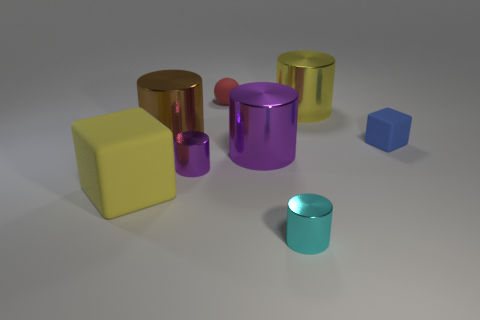Do the small purple cylinder and the cube that is to the left of the tiny cyan shiny cylinder have the same material?
Your answer should be very brief. No. The small cylinder behind the rubber block left of the block right of the tiny cyan shiny cylinder is what color?
Keep it short and to the point. Purple. Is there anything else that has the same shape as the tiny red rubber object?
Make the answer very short. No. Is the number of big yellow metallic cylinders greater than the number of large cyan matte objects?
Keep it short and to the point. Yes. What number of cylinders are behind the cyan metallic object and in front of the large yellow shiny object?
Your answer should be very brief. 3. There is a large yellow object that is to the left of the cyan object; what number of tiny cyan metallic things are to the left of it?
Your response must be concise. 0. Does the yellow object in front of the small blue matte thing have the same size as the red thing that is on the left side of the big purple cylinder?
Your answer should be very brief. No. How many purple shiny things are there?
Give a very brief answer. 2. How many purple cylinders have the same material as the red object?
Provide a short and direct response. 0. Are there the same number of small objects right of the cyan object and cyan metallic objects?
Provide a short and direct response. Yes. 